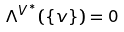Convert formula to latex. <formula><loc_0><loc_0><loc_500><loc_500>\Lambda ^ { V ^ { * } } ( \{ v \} ) = 0</formula> 